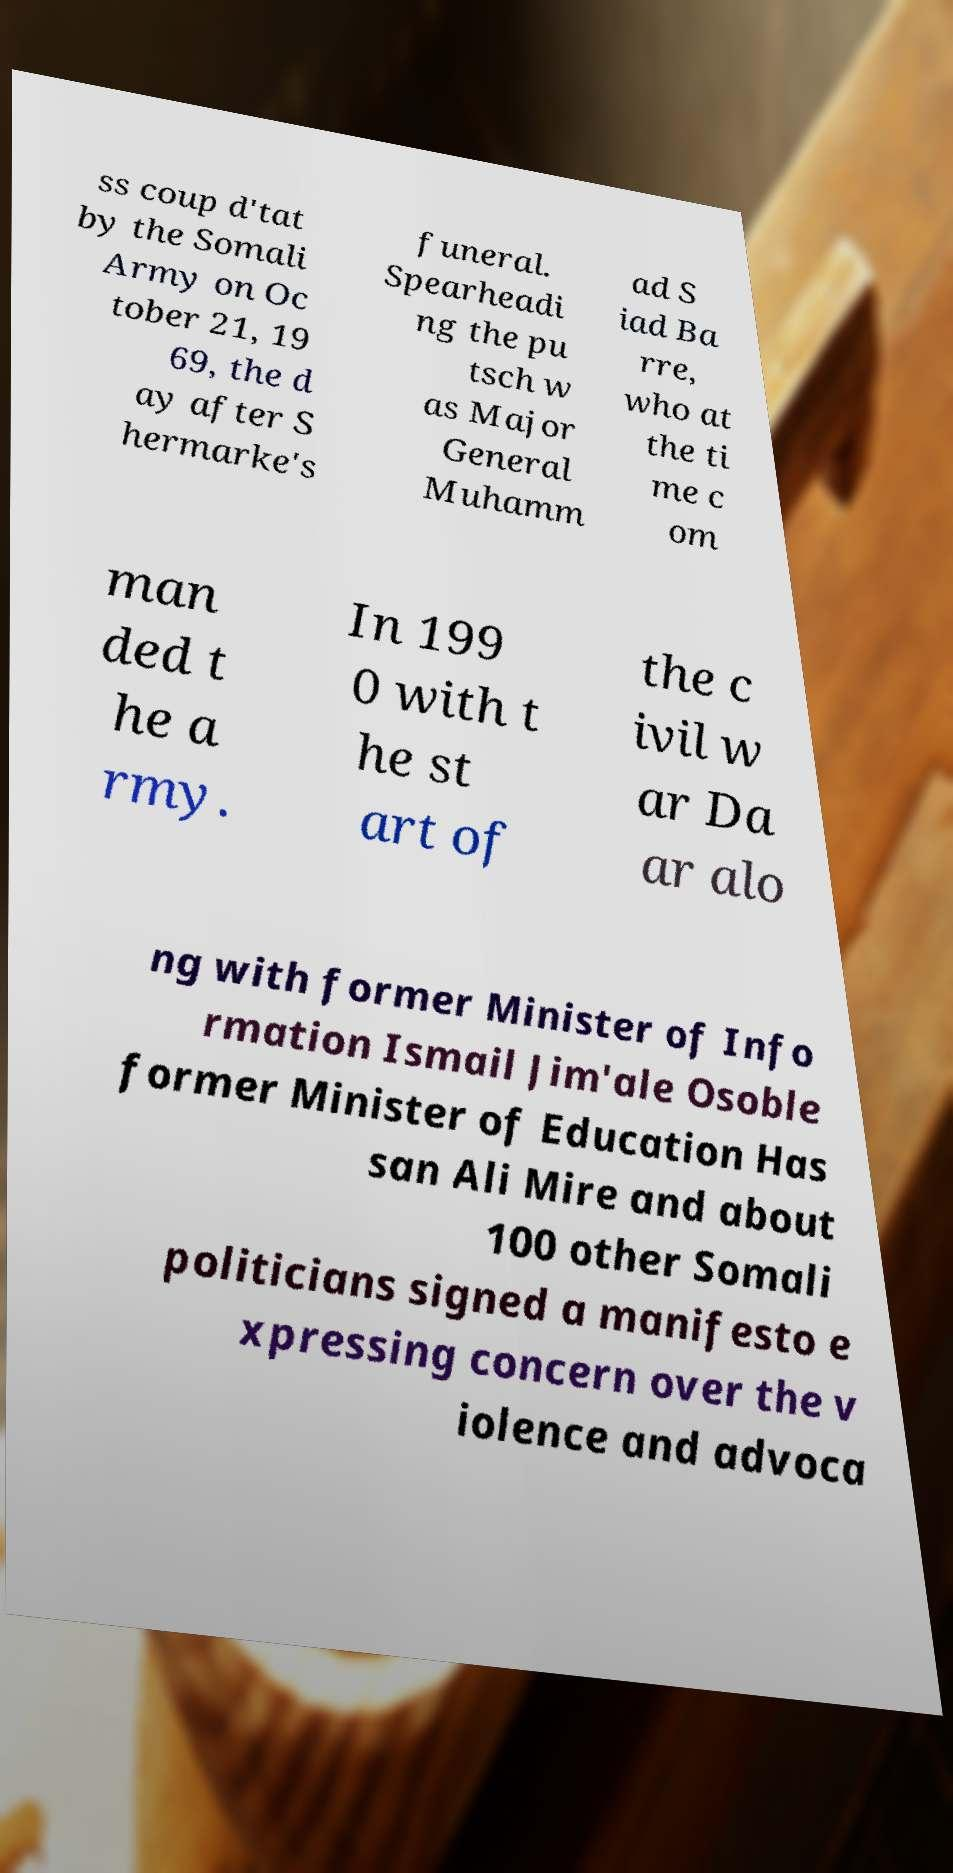Can you read and provide the text displayed in the image?This photo seems to have some interesting text. Can you extract and type it out for me? ss coup d'tat by the Somali Army on Oc tober 21, 19 69, the d ay after S hermarke's funeral. Spearheadi ng the pu tsch w as Major General Muhamm ad S iad Ba rre, who at the ti me c om man ded t he a rmy. In 199 0 with t he st art of the c ivil w ar Da ar alo ng with former Minister of Info rmation Ismail Jim'ale Osoble former Minister of Education Has san Ali Mire and about 100 other Somali politicians signed a manifesto e xpressing concern over the v iolence and advoca 